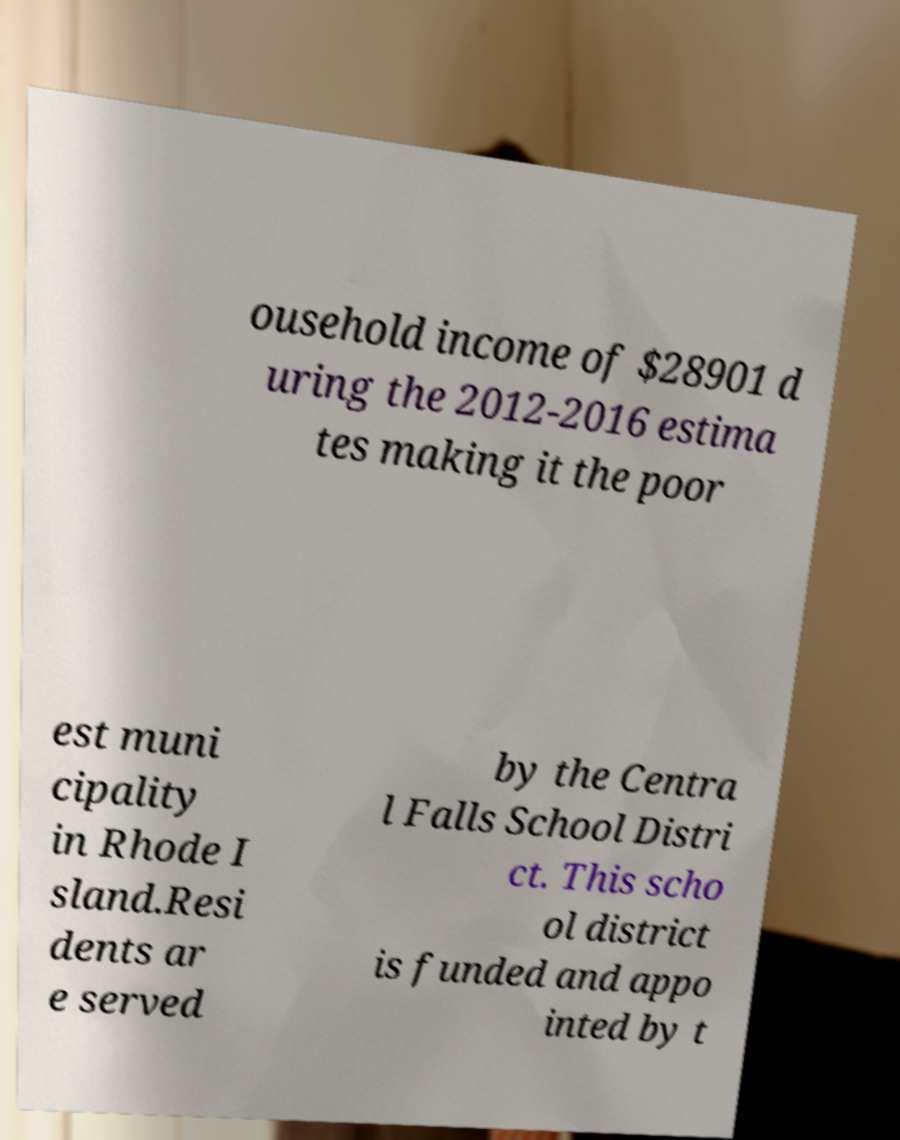What messages or text are displayed in this image? I need them in a readable, typed format. ousehold income of $28901 d uring the 2012-2016 estima tes making it the poor est muni cipality in Rhode I sland.Resi dents ar e served by the Centra l Falls School Distri ct. This scho ol district is funded and appo inted by t 